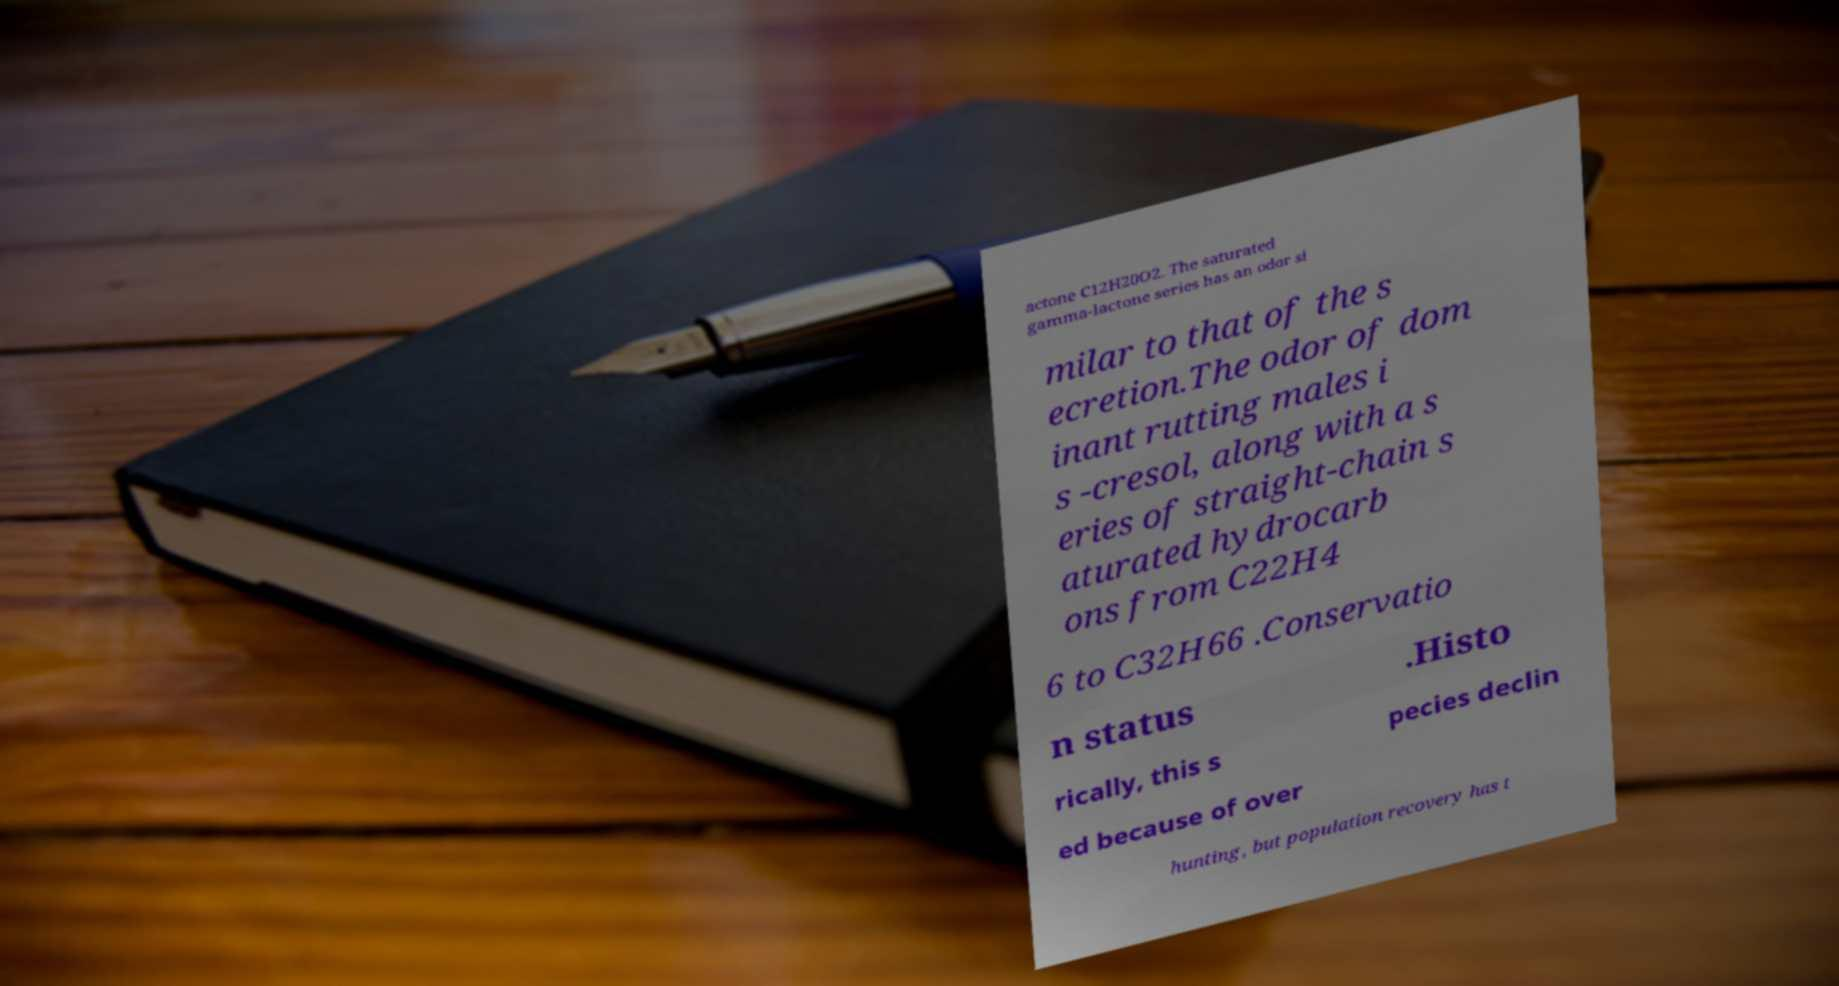What messages or text are displayed in this image? I need them in a readable, typed format. actone C12H20O2. The saturated gamma-lactone series has an odor si milar to that of the s ecretion.The odor of dom inant rutting males i s -cresol, along with a s eries of straight-chain s aturated hydrocarb ons from C22H4 6 to C32H66 .Conservatio n status .Histo rically, this s pecies declin ed because of over hunting, but population recovery has t 